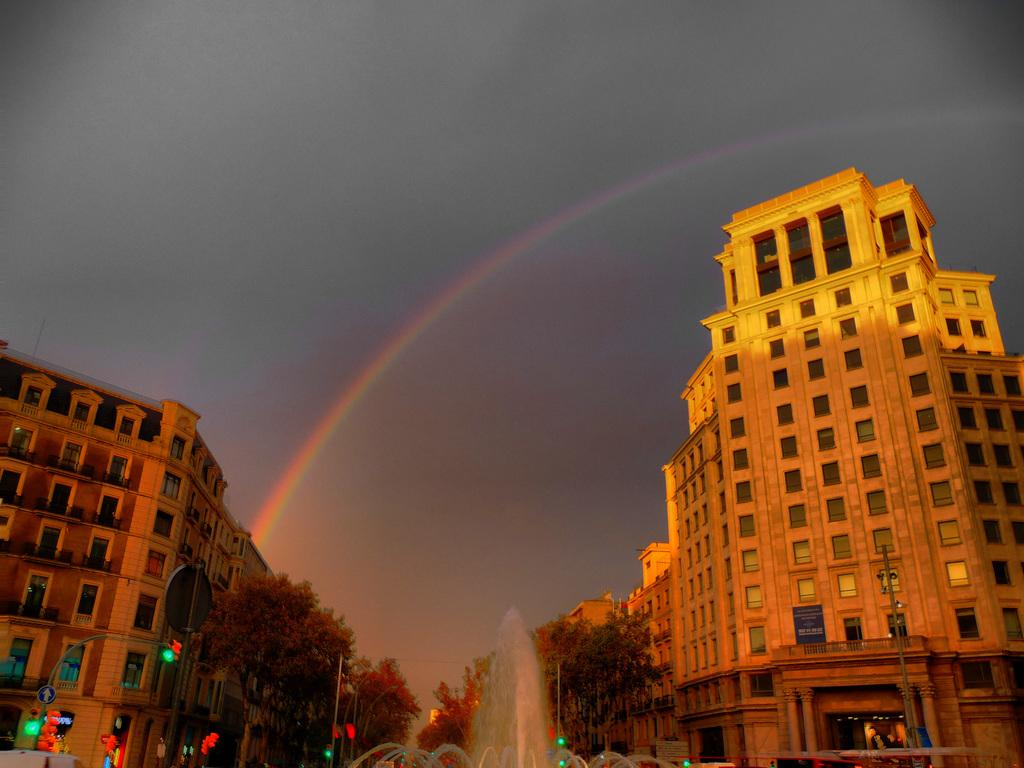What type of structures can be seen in the image? There are buildings in the image. What natural elements are present in the image? There are trees in the image. What type of feature is present in the image that provides water? There is a water fountain in the image. What type of illumination is present in the image? There are lights in the image. What type of man-made structure is present in the image that carries electrical wires? There is an electrical pole in the image. What natural phenomenon can be seen in the image? A rainbow is visible in the image. What is the condition of the sky in the image? The sky is cloudy in the image. How many babies are crawling on the electrical pole in the image? There are no babies present in the image, and the electrical pole is not a surface for crawling. What type of writing instrument is being used by the rainbow in the image? There is no rainbow or writing instrument present in the image. 